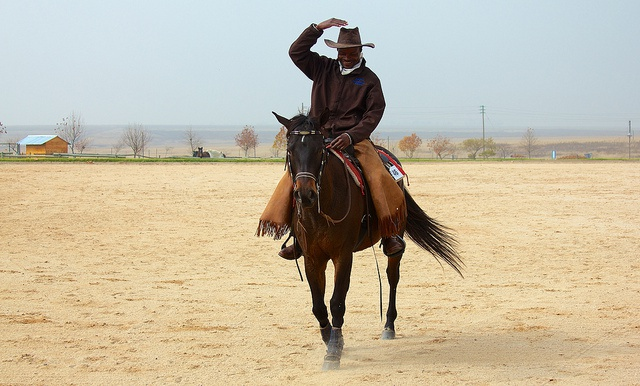Describe the objects in this image and their specific colors. I can see horse in lightgray, black, maroon, gray, and tan tones and people in lightgray, black, maroon, and gray tones in this image. 